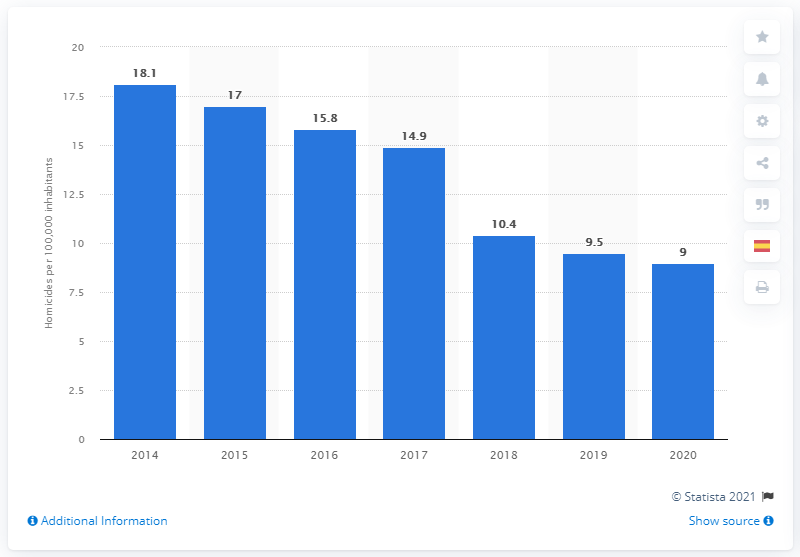Give some essential details in this illustration. The Dominican Republic's homicide rate a year earlier was 9.5... 